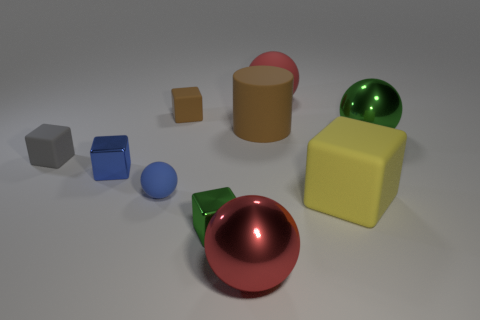Can you tell me how many objects are in this image? Certainly, there are a total of seven objects in this image.  Are all these objects geometric shapes? Yes, each object represents a basic geometric shape such as spheres, cubes, and cylinders. 